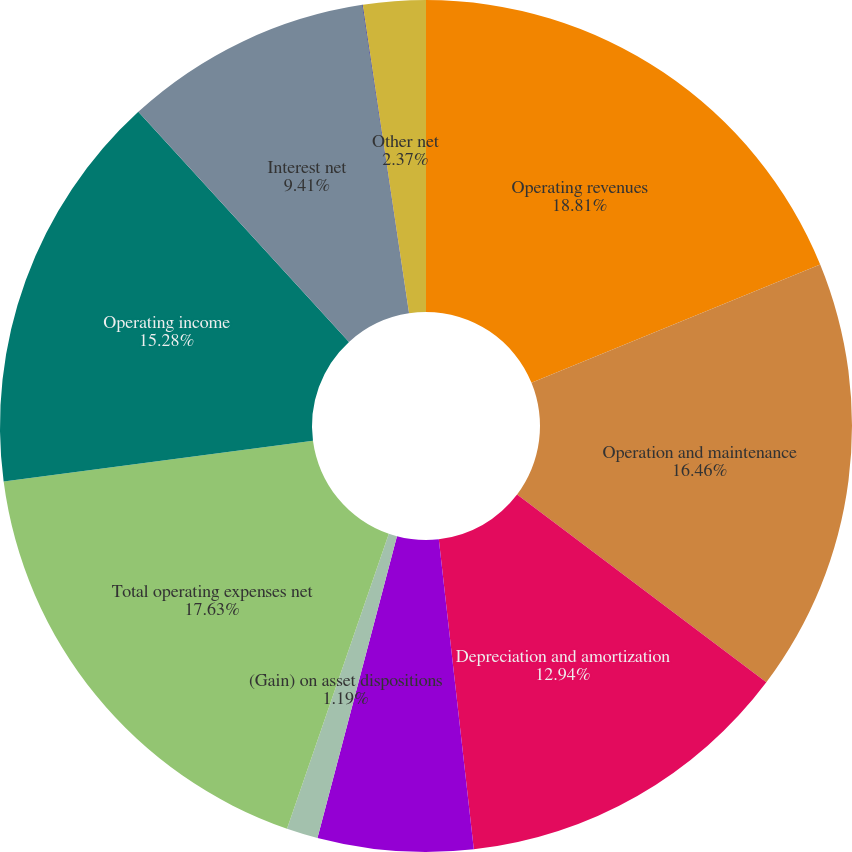<chart> <loc_0><loc_0><loc_500><loc_500><pie_chart><fcel>Operating revenues<fcel>Operation and maintenance<fcel>Depreciation and amortization<fcel>General taxes<fcel>(Gain) on asset dispositions<fcel>Total operating expenses net<fcel>Operating income<fcel>Interest net<fcel>Non-operating benefit costs<fcel>Other net<nl><fcel>18.81%<fcel>16.46%<fcel>12.94%<fcel>5.89%<fcel>1.19%<fcel>17.63%<fcel>15.28%<fcel>9.41%<fcel>0.02%<fcel>2.37%<nl></chart> 